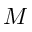Convert formula to latex. <formula><loc_0><loc_0><loc_500><loc_500>M</formula> 